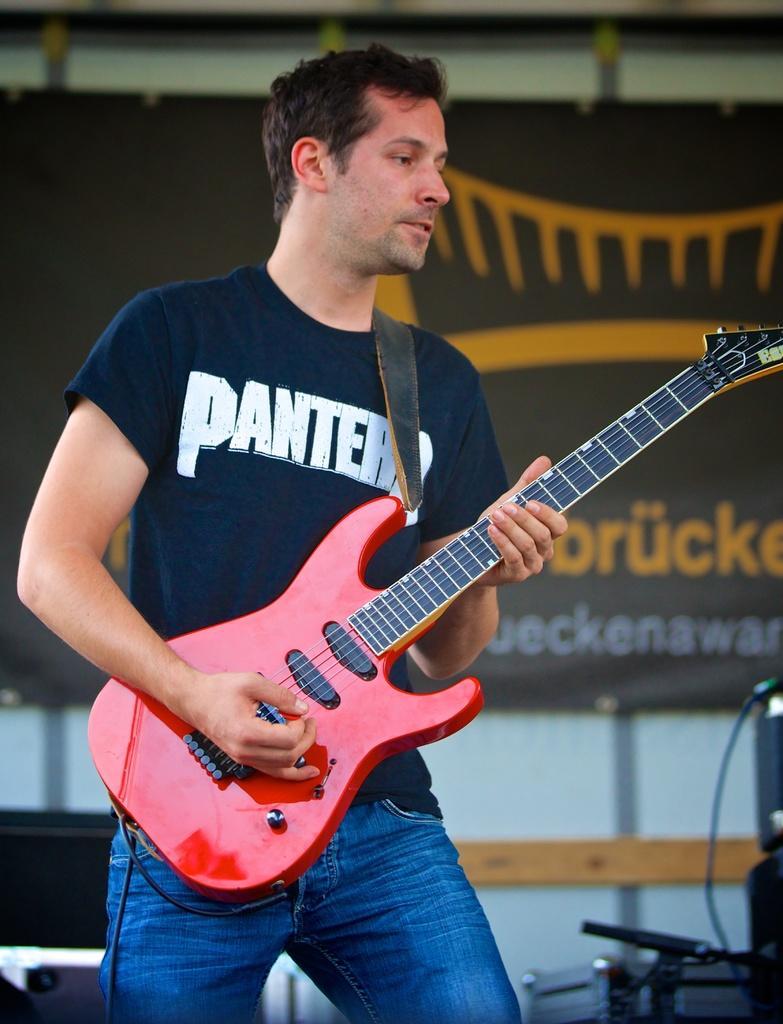In one or two sentences, can you explain what this image depicts? In this image I see a man who is standing and holding a guitar, which is of red and black in color. In the background i see few equipment. 